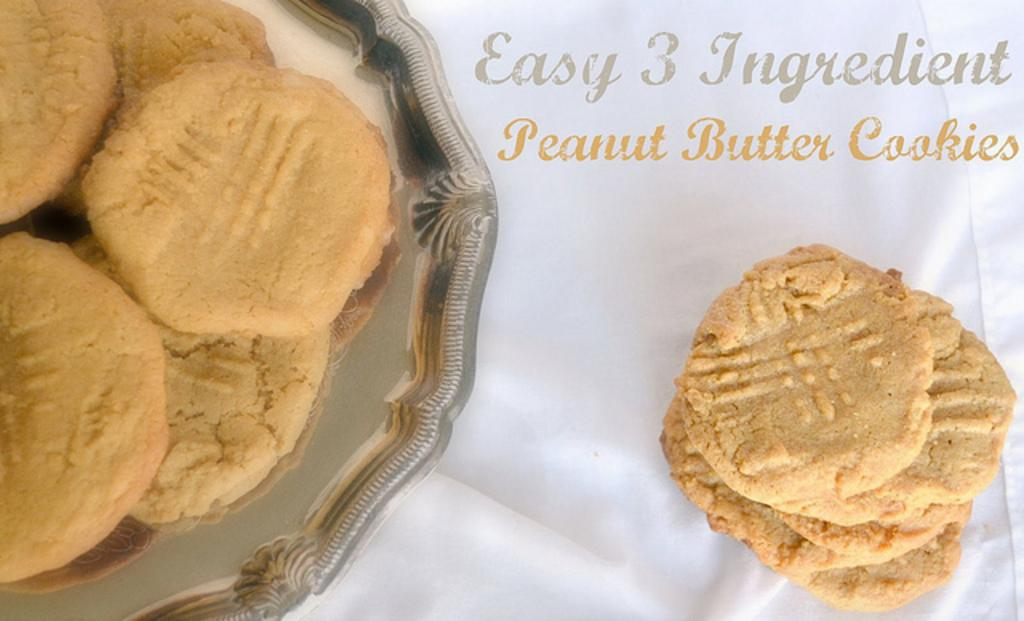What type of food is on the plate in the image? There are cookies on a plate in the image. Where are the cookies located? The cookies are on a table. What can be seen at the top of the image? There is some text at the top of the image. What type of fiction is the air reading in the image? There is no air or reading material present in the image; it features cookies on a plate and text at the top. Is there a crook in the image? There is no crook present in the image. 